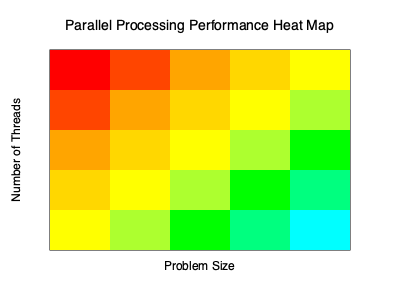Based on the heat map of parallel processing performance, what can we conclude about the relationship between the number of threads, problem size, and execution efficiency? How might this information guide our optimization efforts for our new tech firm's software projects? To analyze the heat map and draw conclusions, let's follow these steps:

1. Interpret the axes:
   - Y-axis: Number of threads (increases from top to bottom)
   - X-axis: Problem size (increases from left to right)

2. Understand the color scheme:
   - Red (top-left corner): Lowest efficiency
   - Blue/Cyan (bottom-right corner): Highest efficiency
   - Colors transition from red to orange, yellow, green, and blue

3. Analyze the pattern:
   a) As we move from top-left to bottom-right, efficiency generally improves.
   b) Increasing the number of threads (moving down) tends to improve performance.
   c) Increasing the problem size (moving right) also tends to improve performance.

4. Identify the sweet spot:
   - The bottom-right corner (highest number of threads, largest problem size) shows the best performance.

5. Observe diminishing returns:
   - The color change becomes less dramatic as we approach the bottom-right corner, indicating diminishing returns.

6. Consider implications for optimization:
   a) For small problem sizes, using fewer threads may be more efficient.
   b) As problem size increases, using more threads becomes more beneficial.
   c) There's a balance to strike between thread count and problem size for optimal performance.

7. Application to our tech firm's projects:
   a) For computationally intensive tasks, we should aim for larger problem sizes and higher thread counts.
   b) For smaller tasks, we should be cautious about over-parallelizing, as it may not yield significant benefits.
   c) We should design our software to dynamically adjust thread count based on the problem size for optimal performance.
Answer: Performance improves with increased threads and problem size, but with diminishing returns. Optimize by balancing thread count and problem size, adjusting dynamically for task complexity. 